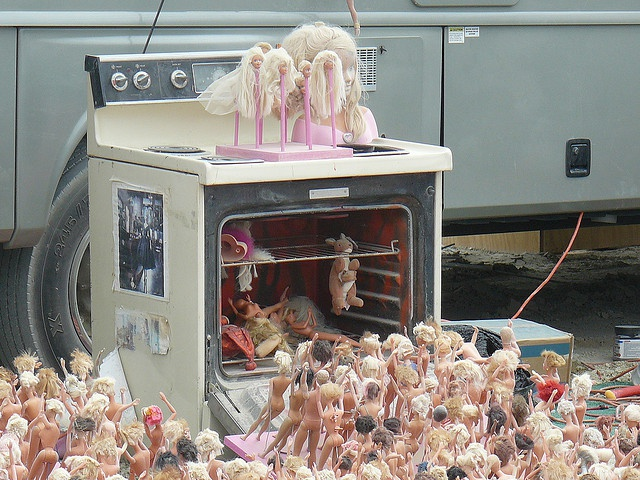Describe the objects in this image and their specific colors. I can see a oven in darkgray, gray, black, and lightgray tones in this image. 